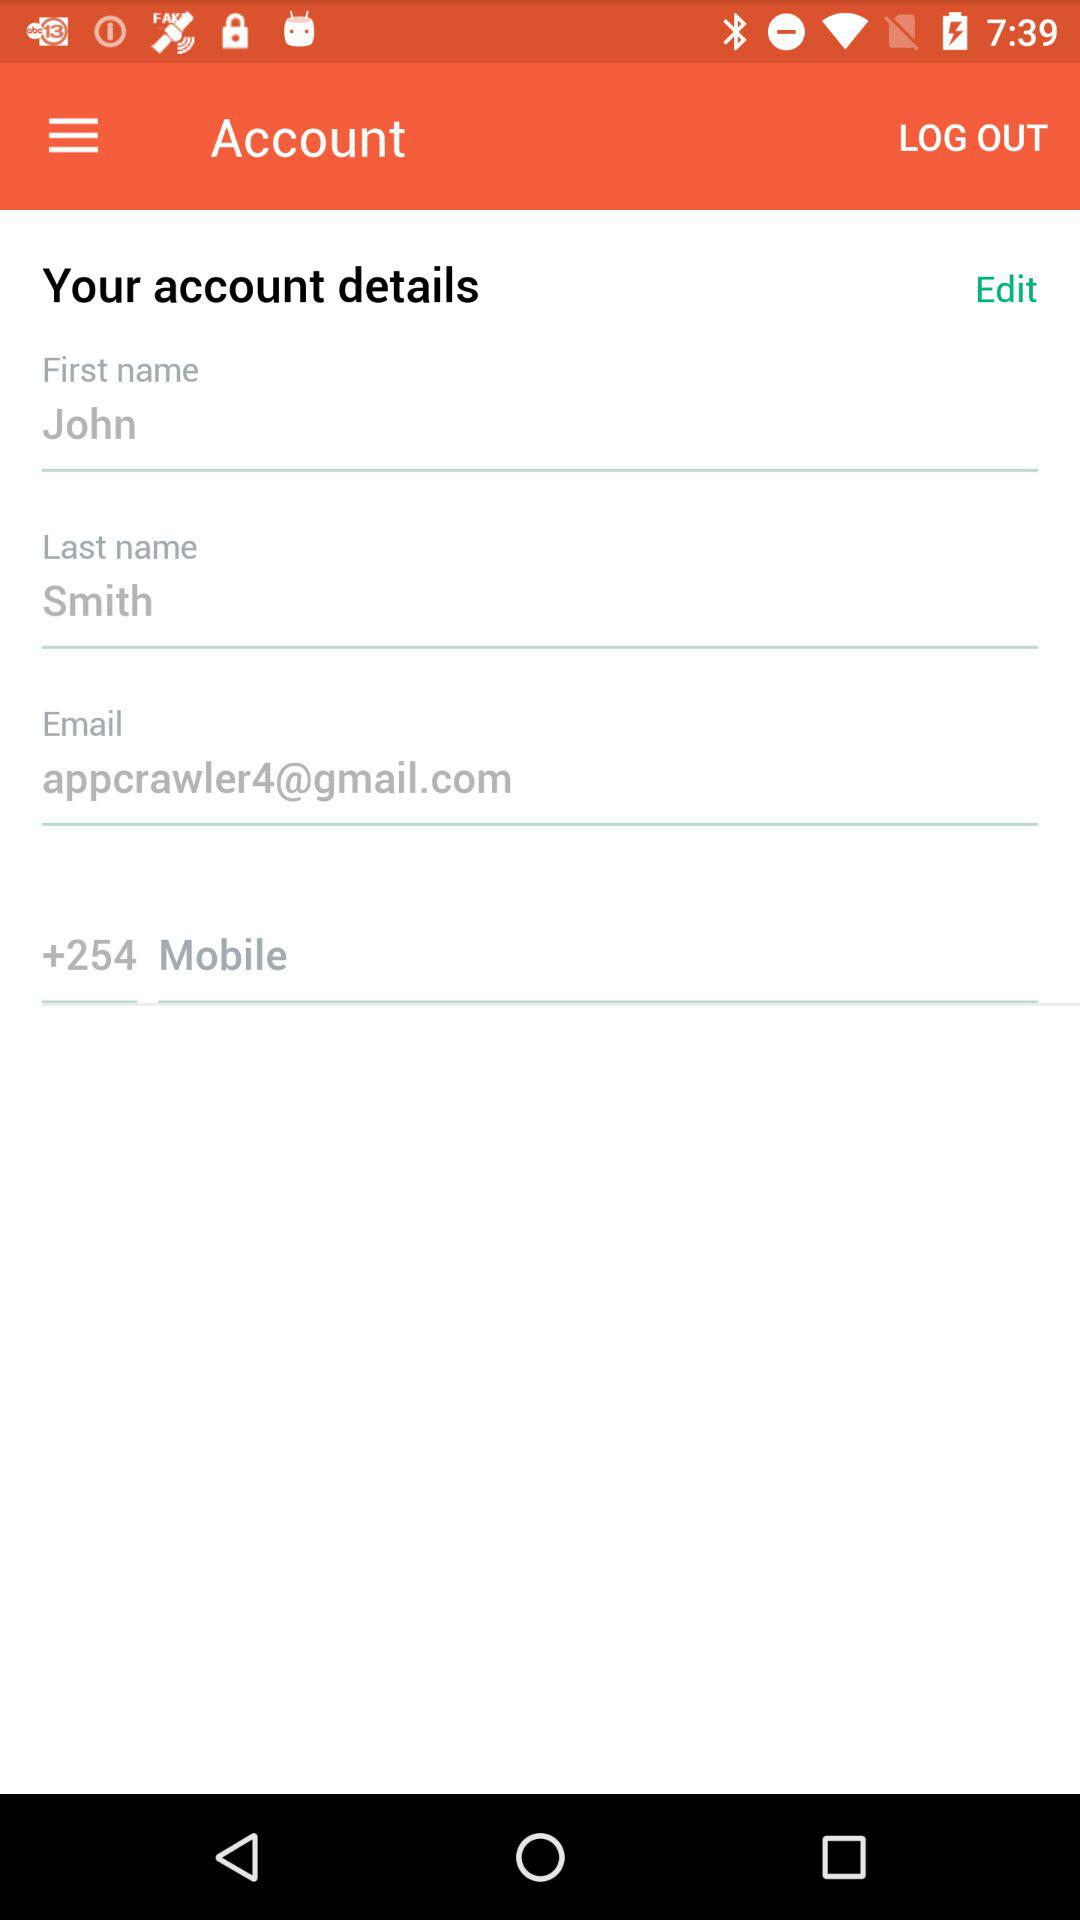What is the name of the user? The name of the user is John Smith. 